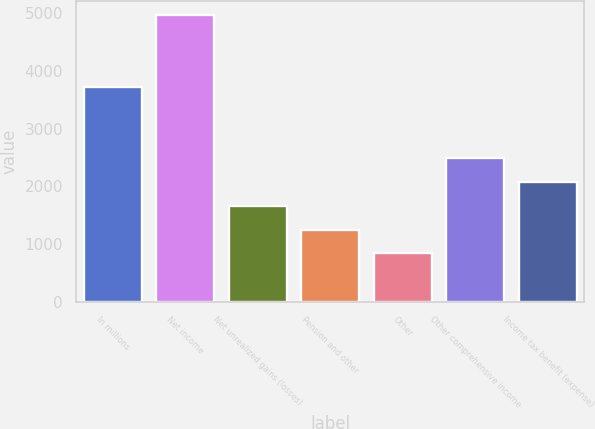<chart> <loc_0><loc_0><loc_500><loc_500><bar_chart><fcel>In millions<fcel>Net income<fcel>Net unrealized gains (losses)<fcel>Pension and other<fcel>Other<fcel>Other comprehensive income<fcel>Income tax benefit (expense)<nl><fcel>3730<fcel>4969<fcel>1665<fcel>1252<fcel>839<fcel>2491<fcel>2078<nl></chart> 